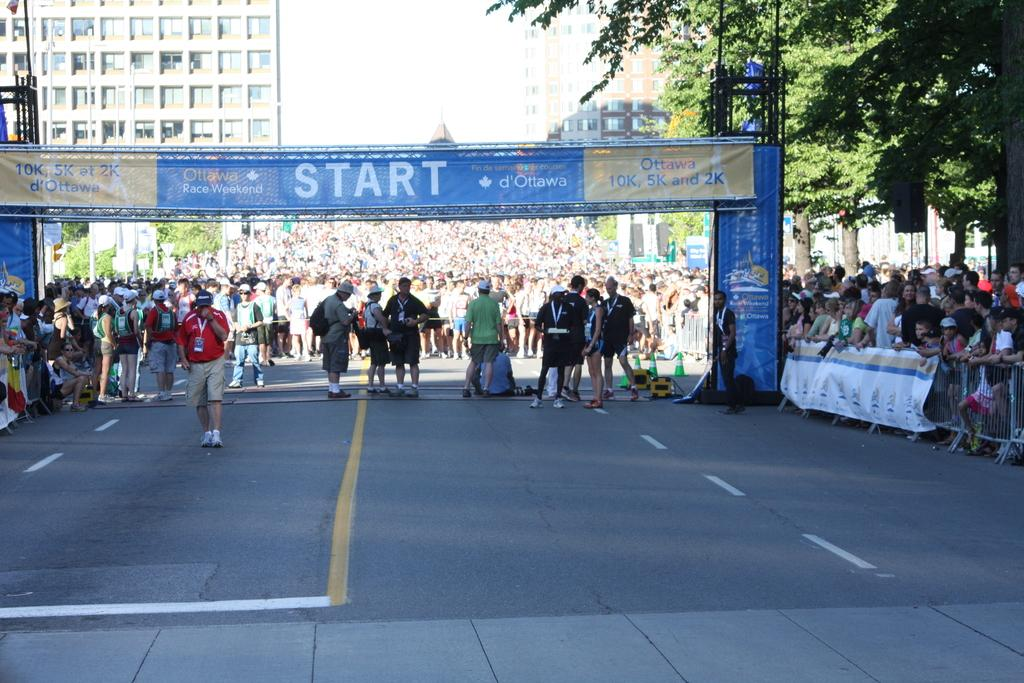What are the people in the image doing? There is a group of persons standing on a road in the image. What is in front of the group of persons? There is a banner in front of the group. What can be seen blocking the road in the image? There is a barricade in the image. What type of vegetation is present in the image? There is a tree in the image. What type of structures are visible in the image? There are buildings in the image. What is visible above the scene in the image? The sky is visible in the image. Can you tell me how many horses are standing with the group of persons in the image? There are no horses present in the image; only a group of persons, a banner, a barricade, a tree, buildings, and the sky are visible. What type of riddle is written on the banner in the image? There is no riddle written on the banner in the image; it only contains a message or information. 